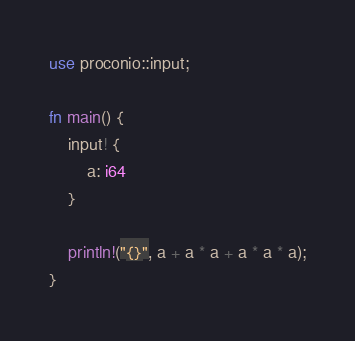<code> <loc_0><loc_0><loc_500><loc_500><_Rust_>use proconio::input;

fn main() {
    input! {
        a: i64
    }

    println!("{}", a + a * a + a * a * a);
}
</code> 